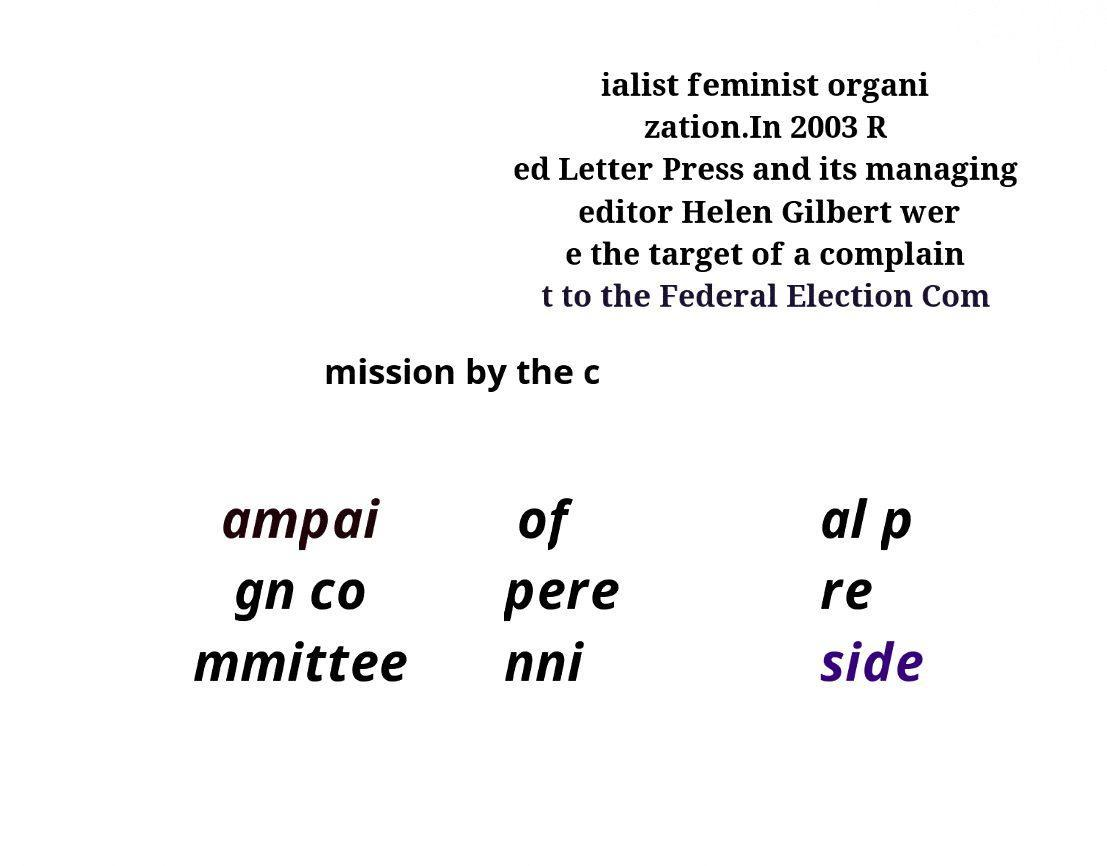Please read and relay the text visible in this image. What does it say? ialist feminist organi zation.In 2003 R ed Letter Press and its managing editor Helen Gilbert wer e the target of a complain t to the Federal Election Com mission by the c ampai gn co mmittee of pere nni al p re side 